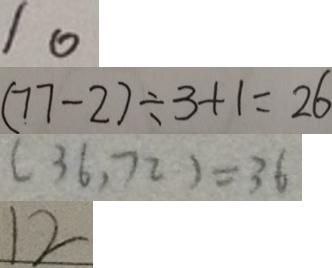Convert formula to latex. <formula><loc_0><loc_0><loc_500><loc_500>1 0 
 ( 7 7 - 2 ) \div 3 + 1 = 2 6 
 ( 3 6 , 7 2 ) = 3 6 
 1 2</formula> 